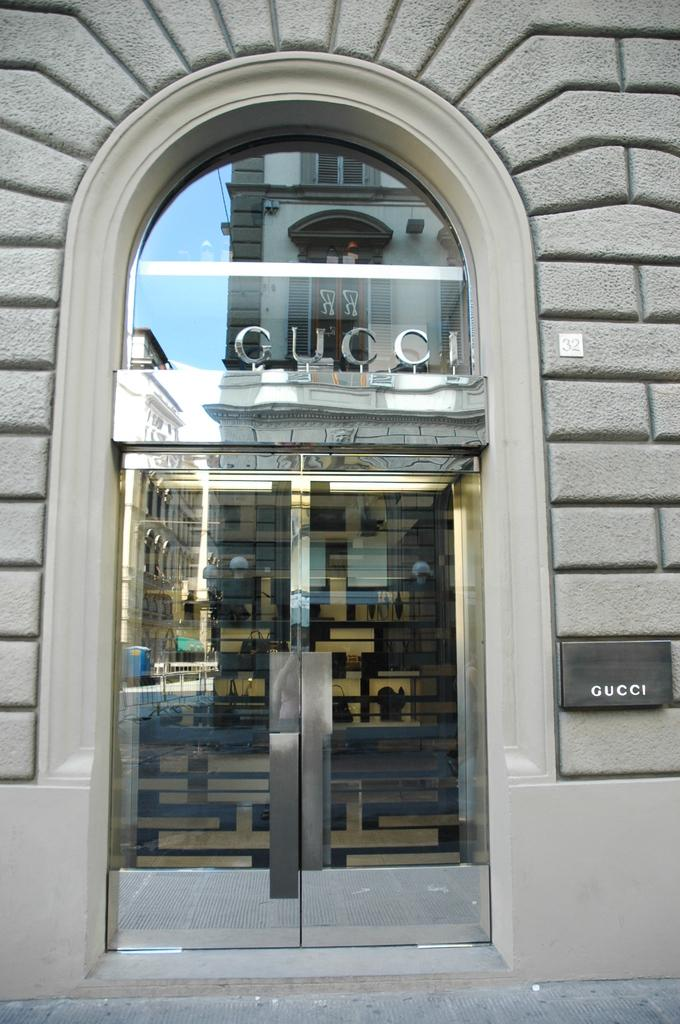What is the main object in the image? There is a door in the image. What does the door lead to? The door leads to a building. What type of board can be seen hanging on the door in the image? There is no board hanging on the door in the image. 